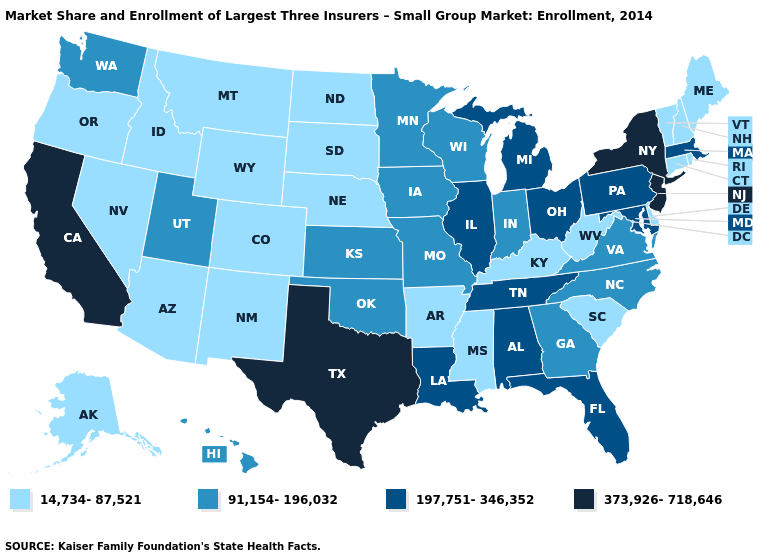Does New York have the lowest value in the Northeast?
Concise answer only. No. Which states have the lowest value in the MidWest?
Quick response, please. Nebraska, North Dakota, South Dakota. What is the value of Delaware?
Answer briefly. 14,734-87,521. What is the value of North Carolina?
Write a very short answer. 91,154-196,032. Does Washington have the lowest value in the West?
Give a very brief answer. No. Name the states that have a value in the range 91,154-196,032?
Concise answer only. Georgia, Hawaii, Indiana, Iowa, Kansas, Minnesota, Missouri, North Carolina, Oklahoma, Utah, Virginia, Washington, Wisconsin. Name the states that have a value in the range 91,154-196,032?
Short answer required. Georgia, Hawaii, Indiana, Iowa, Kansas, Minnesota, Missouri, North Carolina, Oklahoma, Utah, Virginia, Washington, Wisconsin. Which states have the lowest value in the USA?
Answer briefly. Alaska, Arizona, Arkansas, Colorado, Connecticut, Delaware, Idaho, Kentucky, Maine, Mississippi, Montana, Nebraska, Nevada, New Hampshire, New Mexico, North Dakota, Oregon, Rhode Island, South Carolina, South Dakota, Vermont, West Virginia, Wyoming. What is the lowest value in states that border Texas?
Answer briefly. 14,734-87,521. Is the legend a continuous bar?
Keep it brief. No. What is the value of Ohio?
Answer briefly. 197,751-346,352. Name the states that have a value in the range 14,734-87,521?
Concise answer only. Alaska, Arizona, Arkansas, Colorado, Connecticut, Delaware, Idaho, Kentucky, Maine, Mississippi, Montana, Nebraska, Nevada, New Hampshire, New Mexico, North Dakota, Oregon, Rhode Island, South Carolina, South Dakota, Vermont, West Virginia, Wyoming. Among the states that border California , which have the lowest value?
Give a very brief answer. Arizona, Nevada, Oregon. Name the states that have a value in the range 91,154-196,032?
Short answer required. Georgia, Hawaii, Indiana, Iowa, Kansas, Minnesota, Missouri, North Carolina, Oklahoma, Utah, Virginia, Washington, Wisconsin. Does Michigan have the lowest value in the MidWest?
Short answer required. No. 